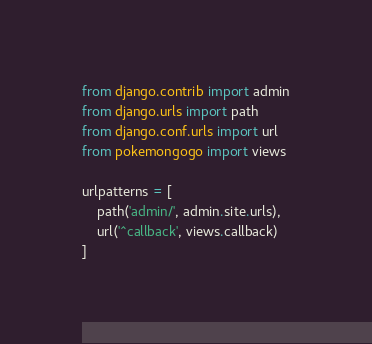<code> <loc_0><loc_0><loc_500><loc_500><_Python_>from django.contrib import admin
from django.urls import path
from django.conf.urls import url
from pokemongogo import views

urlpatterns = [
    path('admin/', admin.site.urls),
    url('^callback', views.callback)
]
</code> 